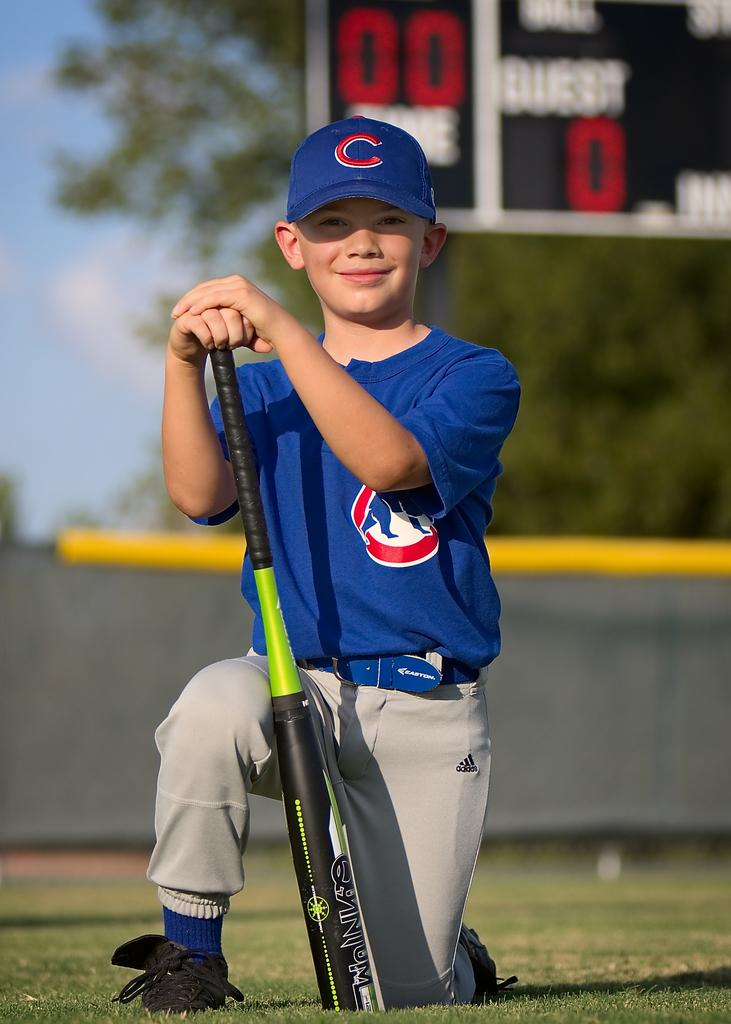What is the main subject of the image? The main subject of the image is a child. What is the child wearing? The child is wearing a blue T-shirt and grey pants. What is the child holding in his hand? The child is holding a baseball bat in his hand. Can you describe the background of the image? The background of the image is blurred. What type of metal can be seen in the image? There is no metal present in the image. Is there a church visible in the background of the image? No, there is no church visible in the image; the background is blurred. 